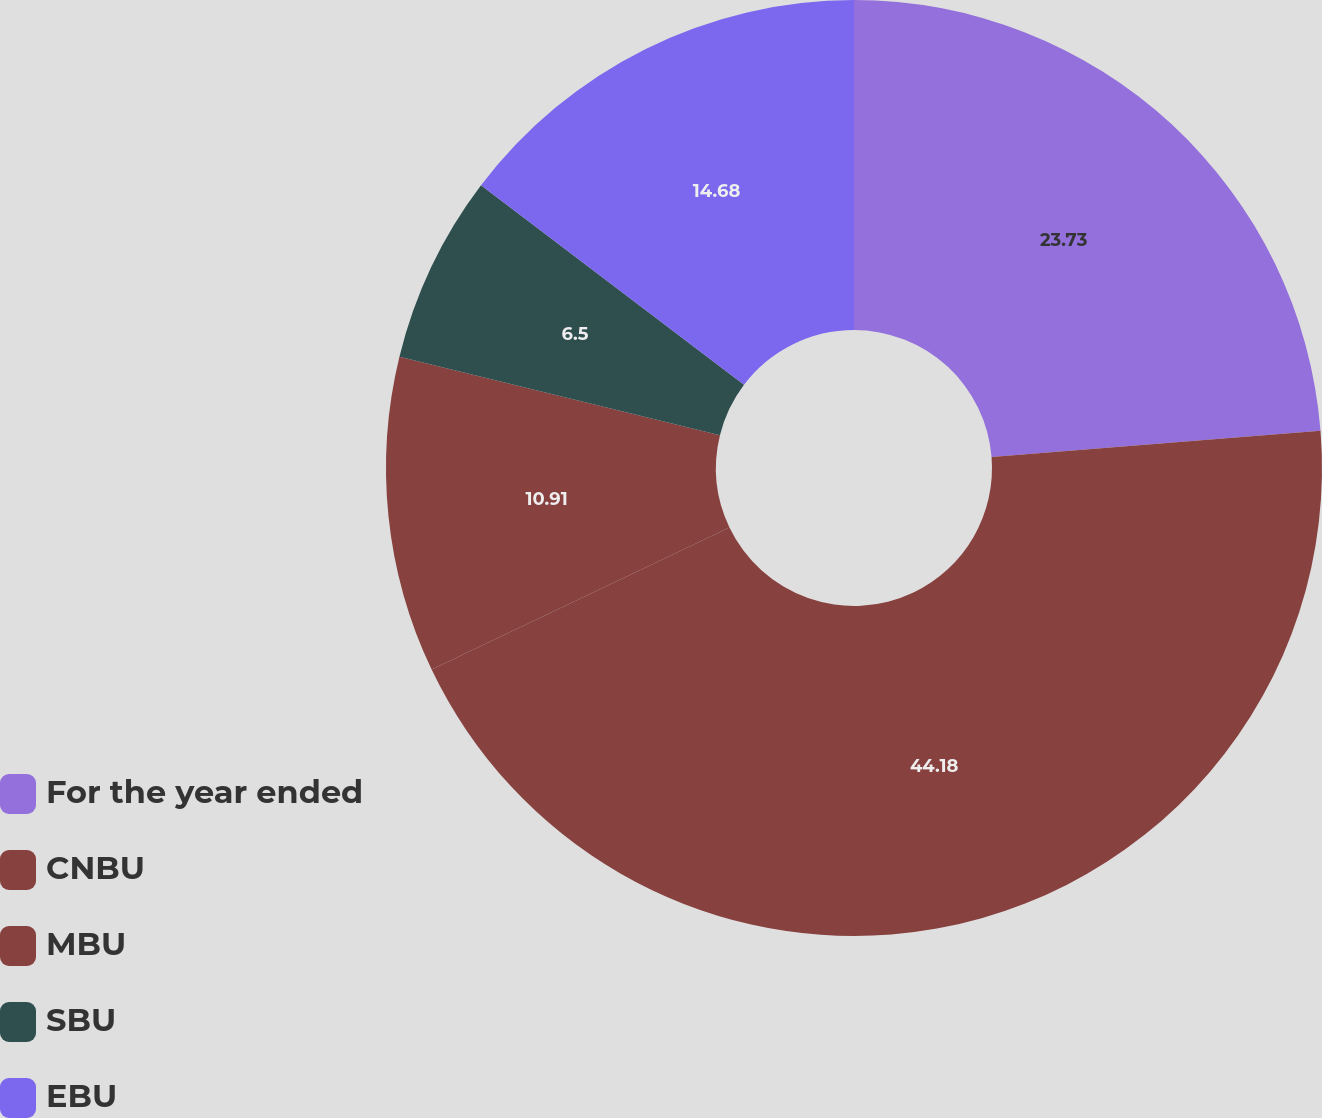Convert chart to OTSL. <chart><loc_0><loc_0><loc_500><loc_500><pie_chart><fcel>For the year ended<fcel>CNBU<fcel>MBU<fcel>SBU<fcel>EBU<nl><fcel>23.73%<fcel>44.19%<fcel>10.91%<fcel>6.5%<fcel>14.68%<nl></chart> 